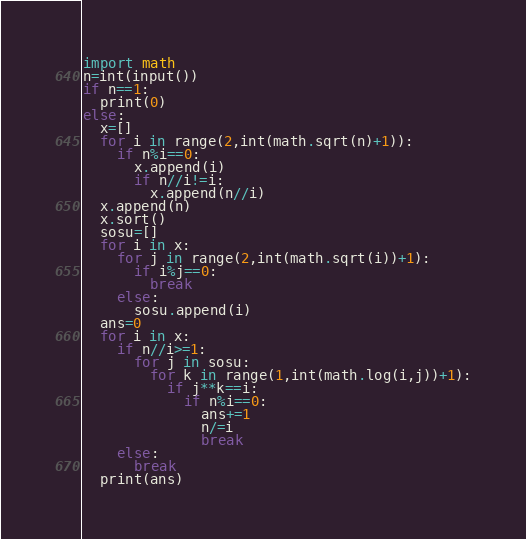<code> <loc_0><loc_0><loc_500><loc_500><_Python_>import math
n=int(input())
if n==1:
  print(0)
else:
  x=[]
  for i in range(2,int(math.sqrt(n)+1)):
    if n%i==0:
      x.append(i)
      if n//i!=i:
        x.append(n//i)
  x.append(n)
  x.sort()
  sosu=[]
  for i in x:
    for j in range(2,int(math.sqrt(i))+1):
      if i%j==0:
        break
    else:
      sosu.append(i)
  ans=0
  for i in x:
    if n//i>=1:
      for j in sosu:
        for k in range(1,int(math.log(i,j))+1):
          if j**k==i:
            if n%i==0:
              ans+=1
              n/=i
              break
    else:
      break
  print(ans)</code> 